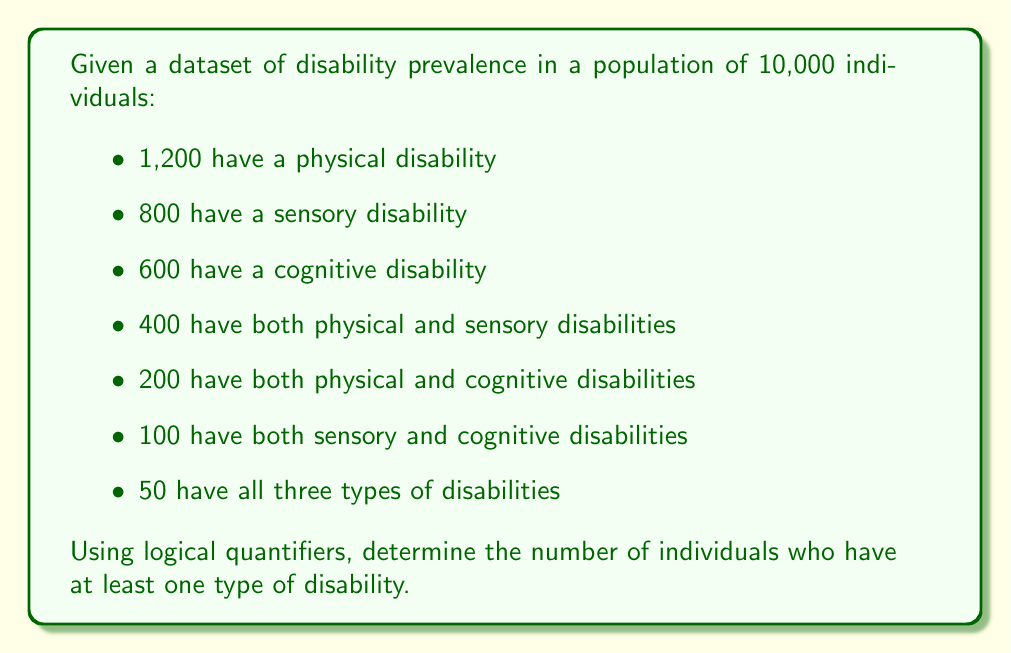Help me with this question. To solve this problem, we'll use the principle of inclusion-exclusion and represent it using logical quantifiers.

Let's define our sets:
P: individuals with physical disabilities
S: individuals with sensory disabilities
C: individuals with cognitive disabilities

We want to find $|P \cup S \cup C|$, which represents the number of individuals with at least one type of disability.

The inclusion-exclusion principle states:

$$|P \cup S \cup C| = |P| + |S| + |C| - |P \cap S| - |P \cap C| - |S \cap C| + |P \cap S \cap C|$$

Using the given data:
$|P| = 1200$
$|S| = 800$
$|C| = 600$
$|P \cap S| = 400$
$|P \cap C| = 200$
$|S \cap C| = 100$
$|P \cap S \cap C| = 50$

Substituting these values:

$$|P \cup S \cup C| = 1200 + 800 + 600 - 400 - 200 - 100 + 50$$

$$|P \cup S \cup C| = 1950$$

Using logical quantifiers, we can express this as:

$$\exists x (P(x) \lor S(x) \lor C(x))$$

This reads as "There exists an x such that x has a physical disability or a sensory disability or a cognitive disability."

The number of individuals satisfying this statement is 1950.
Answer: 1950 individuals have at least one type of disability. 